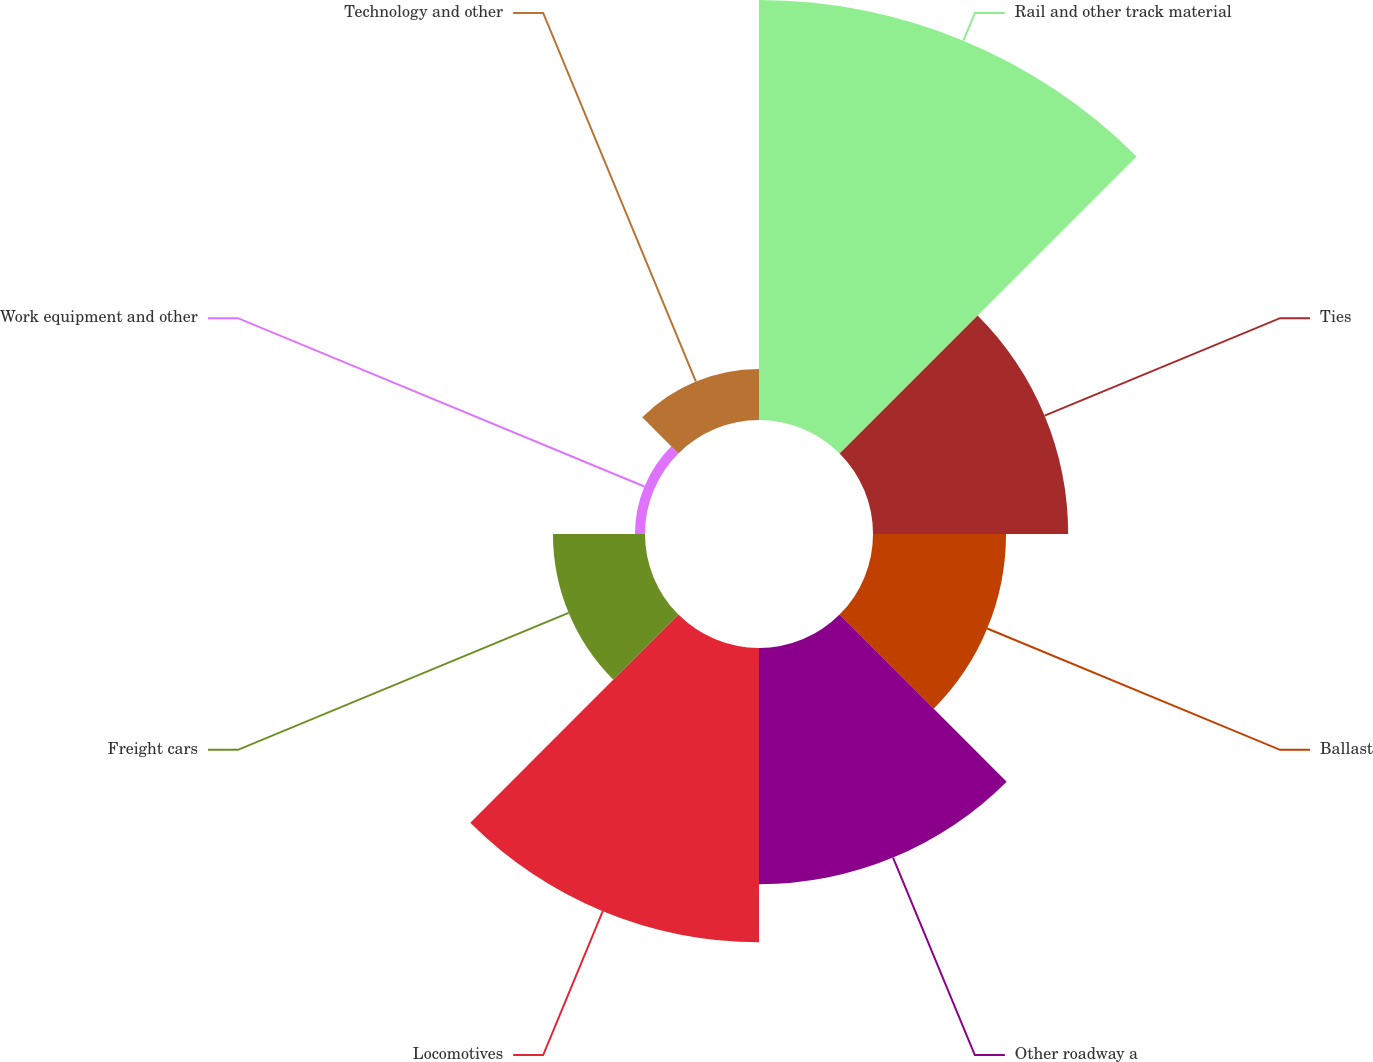Convert chart to OTSL. <chart><loc_0><loc_0><loc_500><loc_500><pie_chart><fcel>Rail and other track material<fcel>Ties<fcel>Ballast<fcel>Other roadway a<fcel>Locomotives<fcel>Freight cars<fcel>Work equipment and other<fcel>Technology and other<nl><fcel>29.33%<fcel>13.63%<fcel>9.29%<fcel>16.5%<fcel>20.55%<fcel>6.43%<fcel>0.7%<fcel>3.57%<nl></chart> 